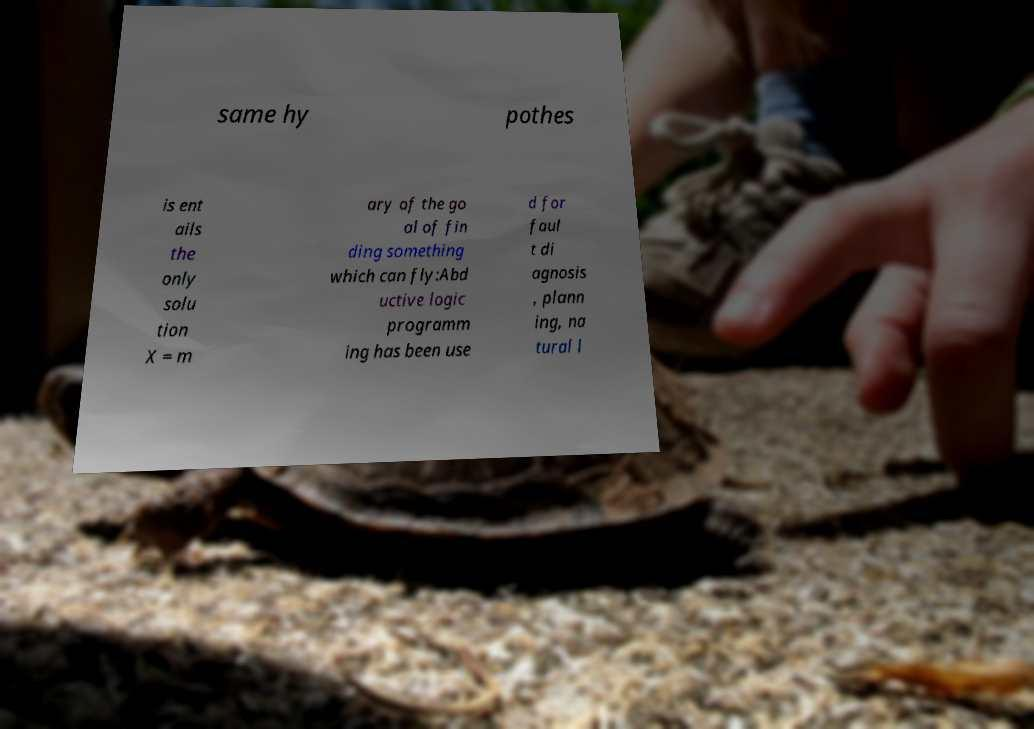Please identify and transcribe the text found in this image. same hy pothes is ent ails the only solu tion X = m ary of the go al of fin ding something which can fly:Abd uctive logic programm ing has been use d for faul t di agnosis , plann ing, na tural l 